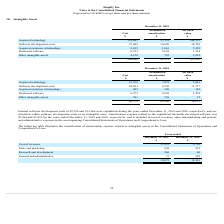From Shopify's financial document, What financial items does intangible assets comprise of? The document contains multiple relevant values: Acquired technology, Software development costs, Acquired customer relationships, Purchased software, Other intangible assets. From the document: "Acquired technology 15,556 7,875 7,681 Purchased software 6,973 4,503 2,470 Acquired customer relationships 495 346 149 Other intangible assets 591 55..." Also, What information does the table show? According to the financial document, Intangible Assets. The relevant text states: "10. Intangible Assets..." Also, What is the cost of acquired technology as at December 31, 2018? According to the financial document, 15,556 (in thousands). The relevant text states: "Acquired technology 15,556 7,875 7,681..." Also, can you calculate: How much is the 2019 software development costs excluding the internal software development costs of $12,666? Based on the calculation: 24,963-12,666, the result is 12297 (in thousands). This is based on the information: "Software development costs 24,963 9,226 15,737 nternal software development costs of $2,526 and $12,666 were capitalized during the years ended December 31, 2019 and 2018, respectively, and are classi..." The key data points involved are: 12,666, 24,963. Also, can you calculate: What is the average amortization expense relating to the capitalized internally developed software for 2018 and 2019? To answer this question, I need to perform calculations using the financial data. The calculation is: (7,464+3,832)/2, which equals 5648 (in thousands). This is based on the information: "zed internally developed software was $7,464 and $3,832 for the years ended December 31, 2019 and 2018, respectively, and is included in cost of revenues, he capitalized internally developed software ..." The key data points involved are: 3,832, 7,464. Additionally, Between 2018 and 2019 year end, which year had a higher amount of intangible assets? Based on the financial document, the answer is 2019. 